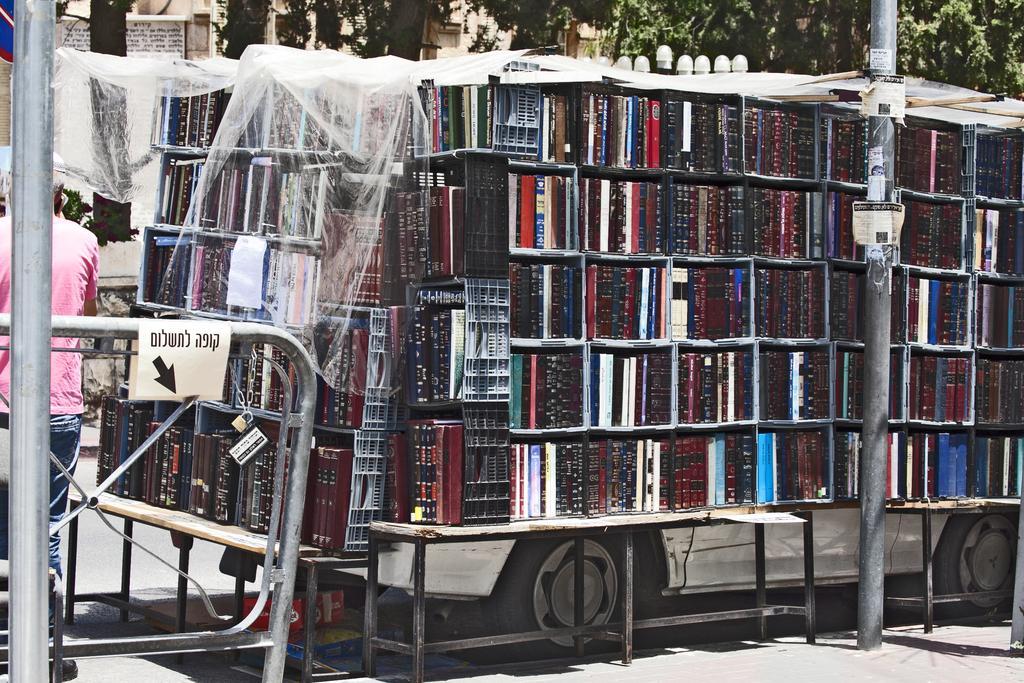In one or two sentences, can you explain what this image depicts? In the picture we can see some books which are arranged in a vehicle, on left side of the picture there is a person wearing pink color T-shirt standing and in the background of the picture there are some trees, houses. 